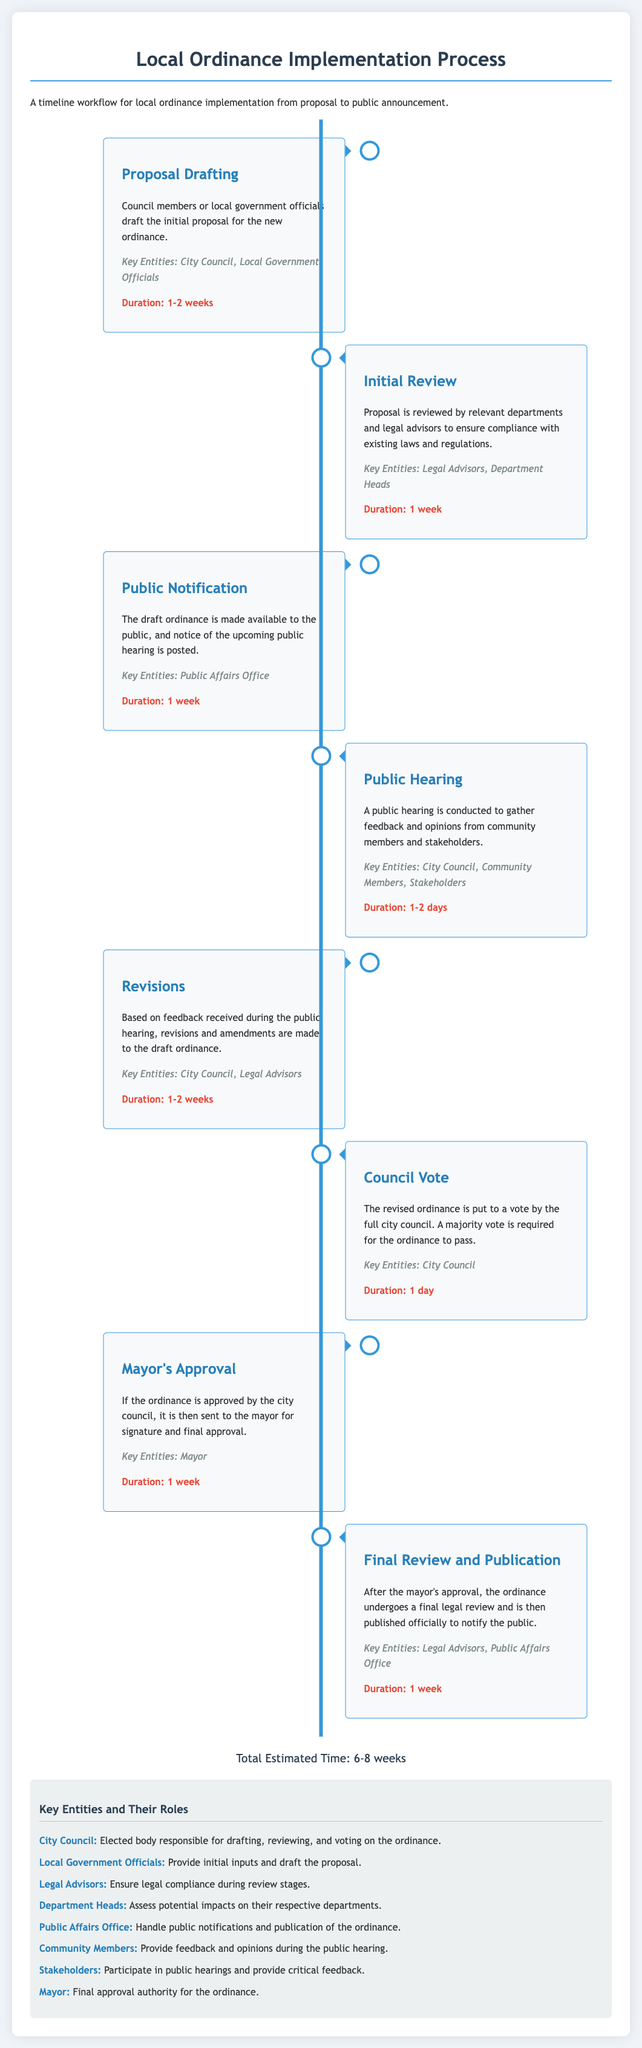What is the duration of Proposal Drafting? The document states that the duration for Proposal Drafting is 1-2 weeks.
Answer: 1-2 weeks Who is responsible for the Initial Review? According to the document, the key entities involved in the Initial Review are Legal Advisors and Department Heads.
Answer: Legal Advisors, Department Heads What milestone follows Public Hearing? The next milestone after Public Hearing is Revisions.
Answer: Revisions How long does the Council Vote take? The duration specified for the Council Vote is 1 day.
Answer: 1 day What is the role of the Mayor in this process? The role of the Mayor is to provide final approval for the ordinance after it has been voted on by the city council.
Answer: Final approval How many total weeks are estimated for the entire process? The total estimated time for the ordinance implementation process is given as 6-8 weeks.
Answer: 6-8 weeks What is the key entity that manages public notifications? The document lists the Public Affairs Office as the entity that handles public notifications.
Answer: Public Affairs Office What happens after Mayor's Approval? After the Mayor's Approval, further legal review and publication of the ordinance take place.
Answer: Final Review and Publication 